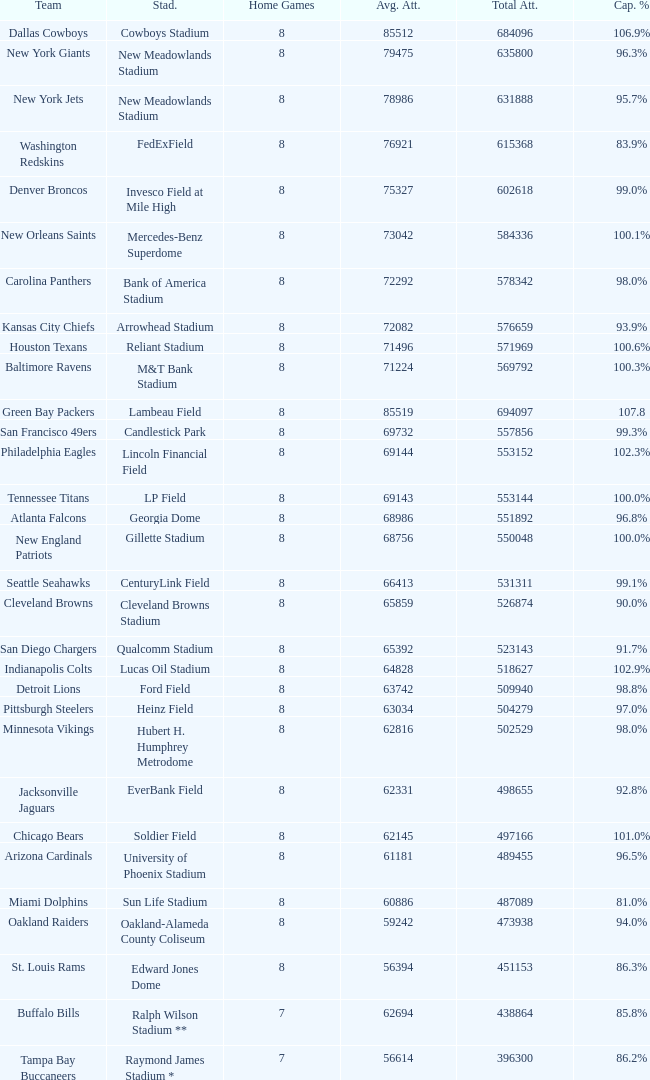What is the name of the stadium when the capacity percentage is 83.9% FedExField. 